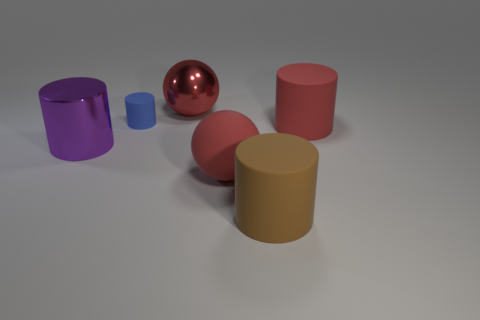Are there any other things that have the same size as the blue matte object?
Give a very brief answer. No. What number of big red metal objects have the same shape as the purple object?
Your answer should be very brief. 0. There is a large thing that is on the left side of the big red ball left of the large rubber sphere; what is its color?
Provide a succinct answer. Purple. Does the brown matte thing have the same shape as the big rubber thing that is left of the brown matte object?
Your response must be concise. No. What material is the red sphere on the left side of the large sphere right of the big shiny object that is right of the small matte object?
Ensure brevity in your answer.  Metal. Is there a metal object of the same size as the purple metallic cylinder?
Offer a very short reply. Yes. The ball that is made of the same material as the purple cylinder is what size?
Offer a very short reply. Large. There is a small blue object; what shape is it?
Your answer should be compact. Cylinder. Is the material of the blue thing the same as the sphere behind the metallic cylinder?
Offer a very short reply. No. What number of things are either large red metal balls or things?
Provide a succinct answer. 6. 